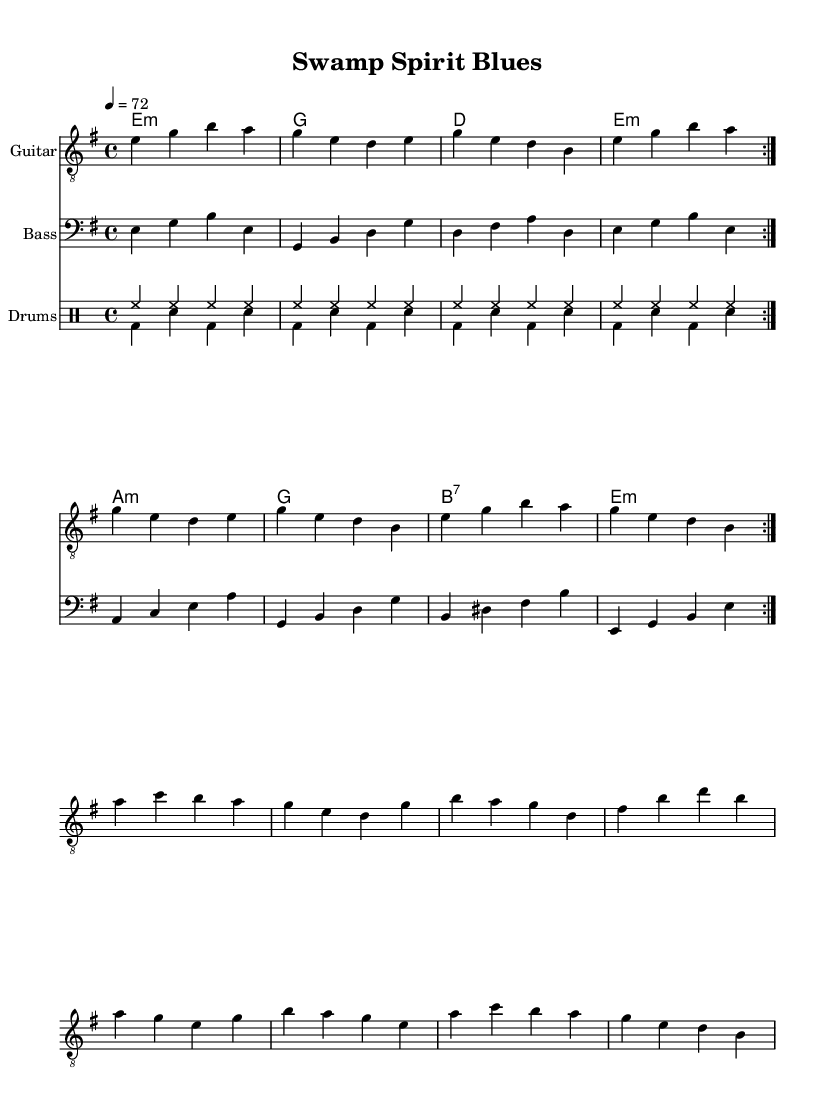What is the key signature of this piece? The key signature is E minor, which has one sharp (F#). This can be determined by looking at the key signature indicated at the beginning of the music, where the sharp symbol is placed on the F line.
Answer: E minor What is the time signature of this music? The time signature is 4/4, which is indicated at the beginning of the piece. This means there are four beats in each measure and a quarter note receives one beat.
Answer: 4/4 What is the tempo marking for this piece? The tempo marking is 4 = 72, showing that there are 72 quarter note beats per minute. This is located at the start of the score, indicating how fast the piece should be played.
Answer: 72 How many measures are in the first section of guitar music? There are eight measures in the first section of guitar music. This is determined by counting the number of measures before the break indicated in the score.
Answer: 8 What chord is used at the beginning of the song? The first chord used is E minor, which is indicated at the beginning of the chord progression shown above the guitar staff.
Answer: E minor What type of rhythm is primarily used in the drum section? The primary rhythm used is a steady eighth note rhythm in the hi-hats, seen in the drum part labeled as "drumsUp." This pattern consists of consistent eighth notes across the measures.
Answer: Eighth note What is the last chord in the sequence of chords? The last chord is E minor, which is guided by the chord progression that ends on E minor after the series of other chords.
Answer: E minor 